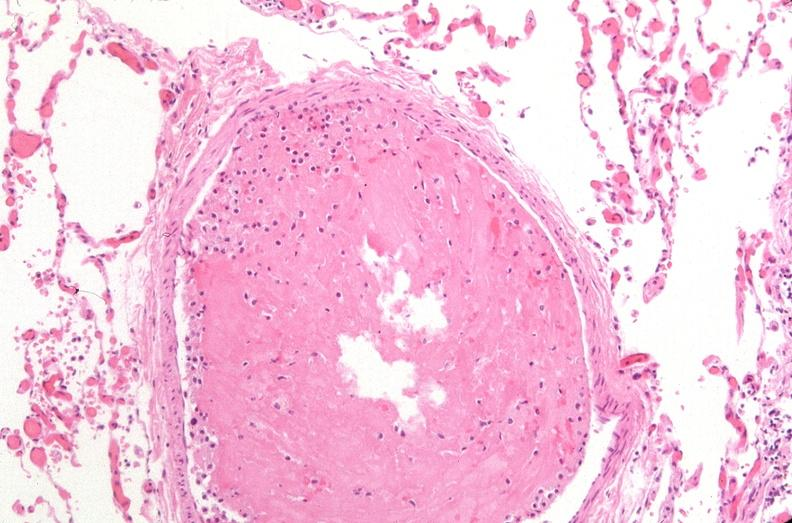s this person present?
Answer the question using a single word or phrase. No 